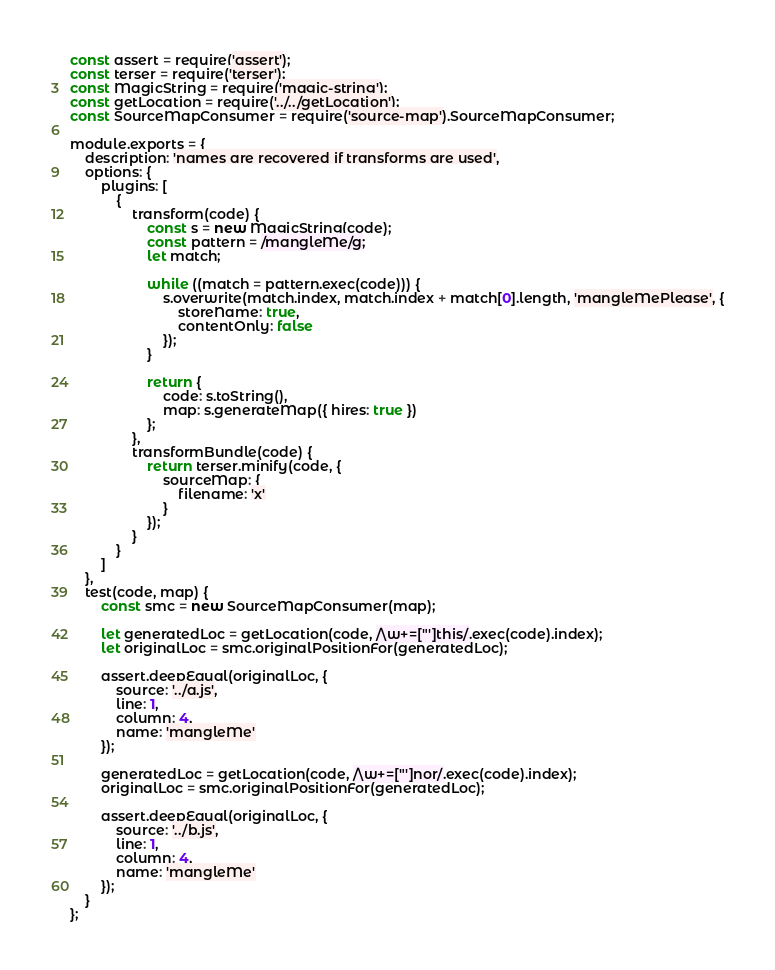Convert code to text. <code><loc_0><loc_0><loc_500><loc_500><_JavaScript_>const assert = require('assert');
const terser = require('terser');
const MagicString = require('magic-string');
const getLocation = require('../../getLocation');
const SourceMapConsumer = require('source-map').SourceMapConsumer;

module.exports = {
	description: 'names are recovered if transforms are used',
	options: {
		plugins: [
			{
				transform(code) {
					const s = new MagicString(code);
					const pattern = /mangleMe/g;
					let match;

					while ((match = pattern.exec(code))) {
						s.overwrite(match.index, match.index + match[0].length, 'mangleMePlease', {
							storeName: true,
							contentOnly: false
						});
					}

					return {
						code: s.toString(),
						map: s.generateMap({ hires: true })
					};
				},
				transformBundle(code) {
					return terser.minify(code, {
						sourceMap: {
							filename: 'x'
						}
					});
				}
			}
		]
	},
	test(code, map) {
		const smc = new SourceMapConsumer(map);

		let generatedLoc = getLocation(code, /\w+=["']this/.exec(code).index);
		let originalLoc = smc.originalPositionFor(generatedLoc);

		assert.deepEqual(originalLoc, {
			source: '../a.js',
			line: 1,
			column: 4,
			name: 'mangleMe'
		});

		generatedLoc = getLocation(code, /\w+=["']nor/.exec(code).index);
		originalLoc = smc.originalPositionFor(generatedLoc);

		assert.deepEqual(originalLoc, {
			source: '../b.js',
			line: 1,
			column: 4,
			name: 'mangleMe'
		});
	}
};
</code> 